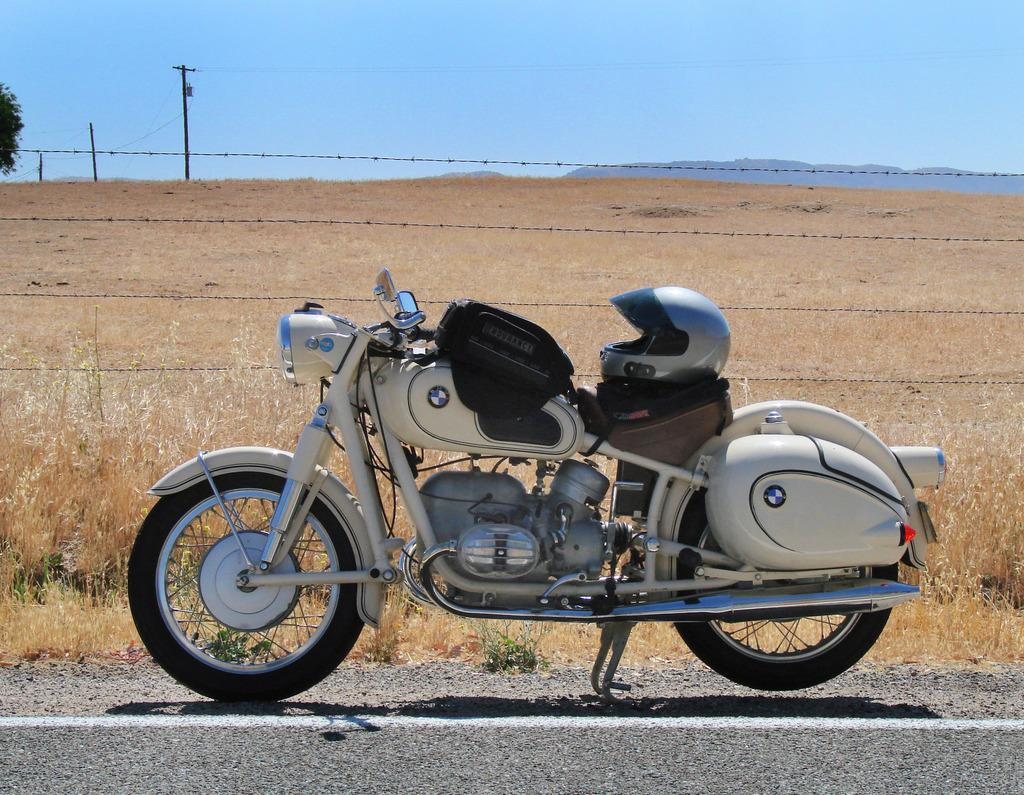What type of vehicle is in the image? There is a white bike in the image. What safety accessory is on the bike? There is a helmet on the bike. What can be seen at the bottom of the image? There is a road at the bottom of the image. What type of landscape is visible in the background of the image? There is a field with dry grass in the background of the image. What type of comb is used to style the bike's handlebars in the image? There is no comb present in the image, and the bike's handlebars do not require styling. 